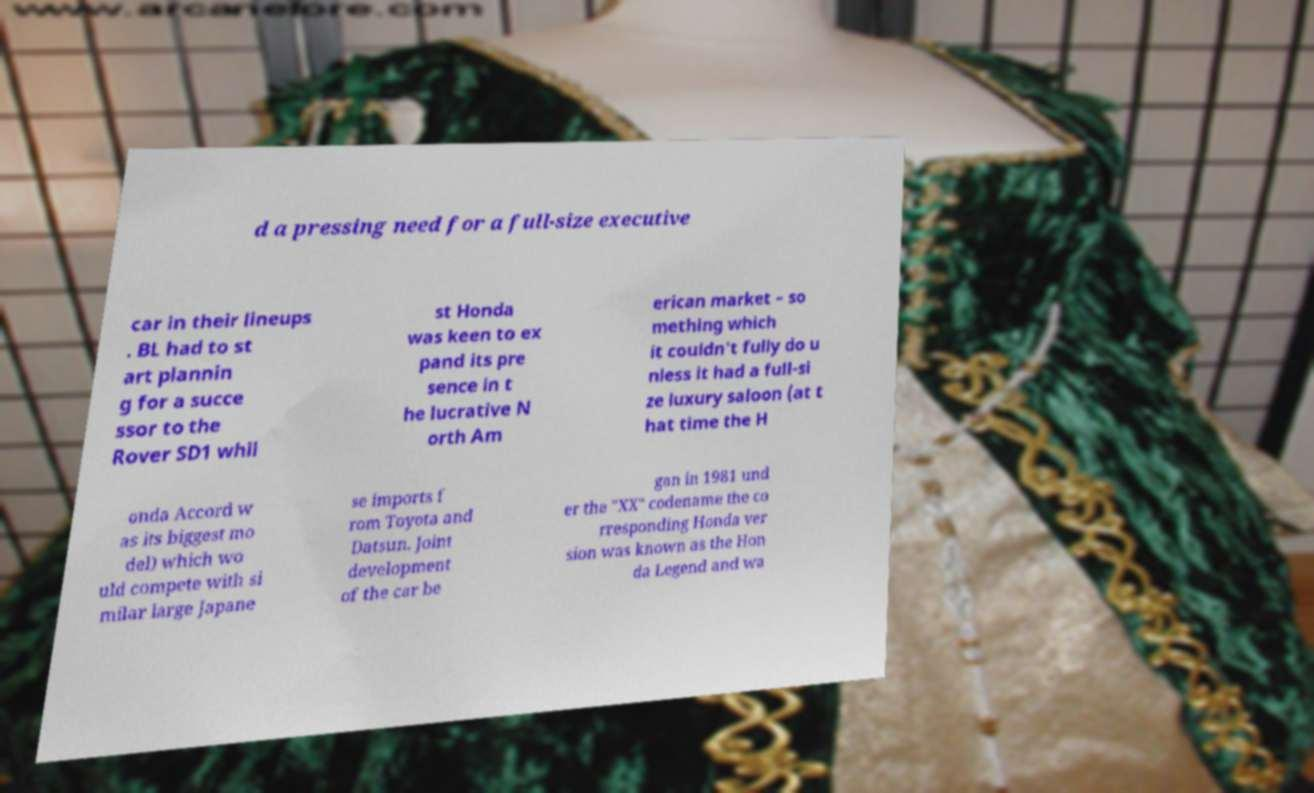I need the written content from this picture converted into text. Can you do that? d a pressing need for a full-size executive car in their lineups . BL had to st art plannin g for a succe ssor to the Rover SD1 whil st Honda was keen to ex pand its pre sence in t he lucrative N orth Am erican market – so mething which it couldn't fully do u nless it had a full-si ze luxury saloon (at t hat time the H onda Accord w as its biggest mo del) which wo uld compete with si milar large Japane se imports f rom Toyota and Datsun. Joint development of the car be gan in 1981 und er the "XX" codename the co rresponding Honda ver sion was known as the Hon da Legend and wa 